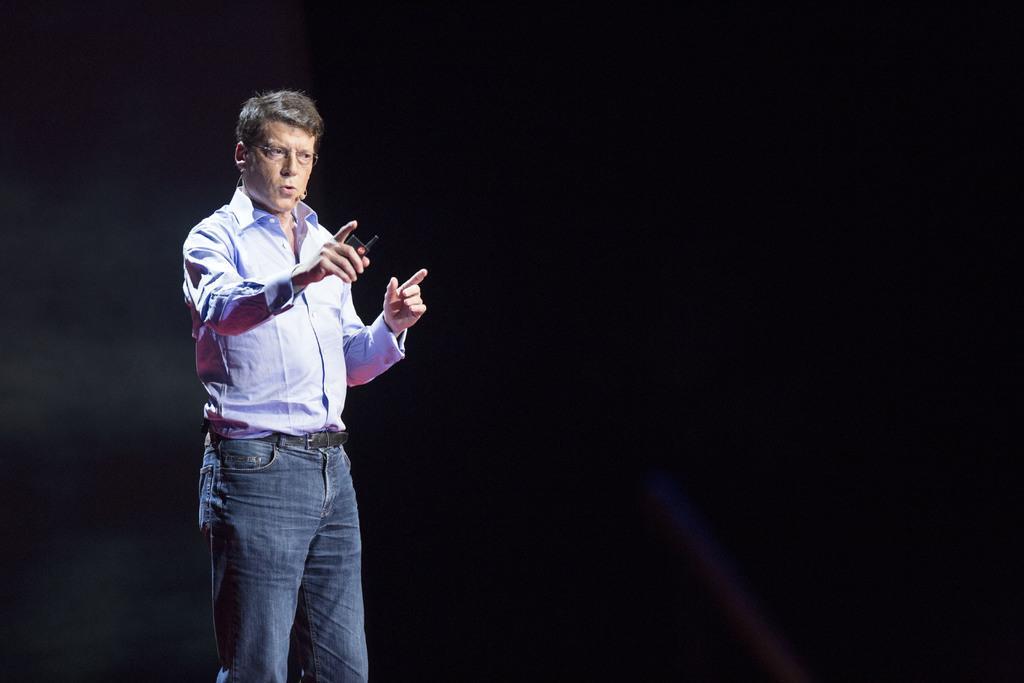Can you describe this image briefly? In the middle of the image a man is standing and holding an electronic device. 